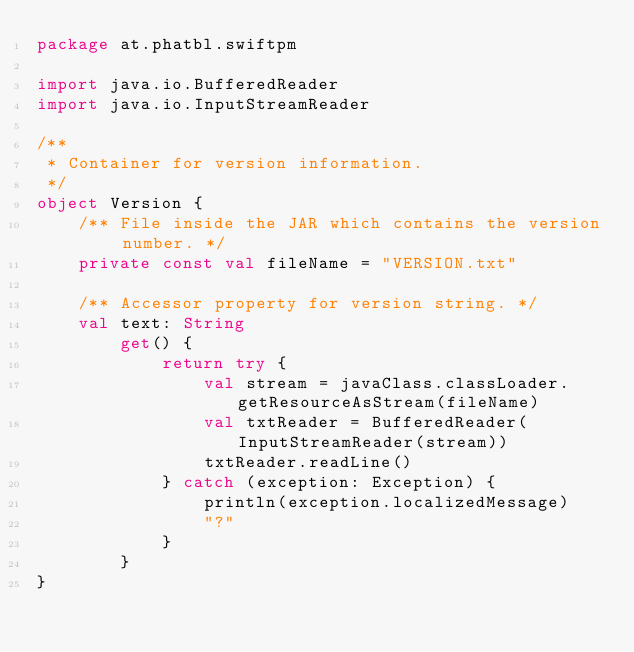<code> <loc_0><loc_0><loc_500><loc_500><_Kotlin_>package at.phatbl.swiftpm

import java.io.BufferedReader
import java.io.InputStreamReader

/**
 * Container for version information.
 */
object Version {
    /** File inside the JAR which contains the version number. */
    private const val fileName = "VERSION.txt"

    /** Accessor property for version string. */
    val text: String
        get() {
            return try {
                val stream = javaClass.classLoader.getResourceAsStream(fileName)
                val txtReader = BufferedReader(InputStreamReader(stream))
                txtReader.readLine()
            } catch (exception: Exception) {
                println(exception.localizedMessage)
                "?"
            }
        }
}
</code> 